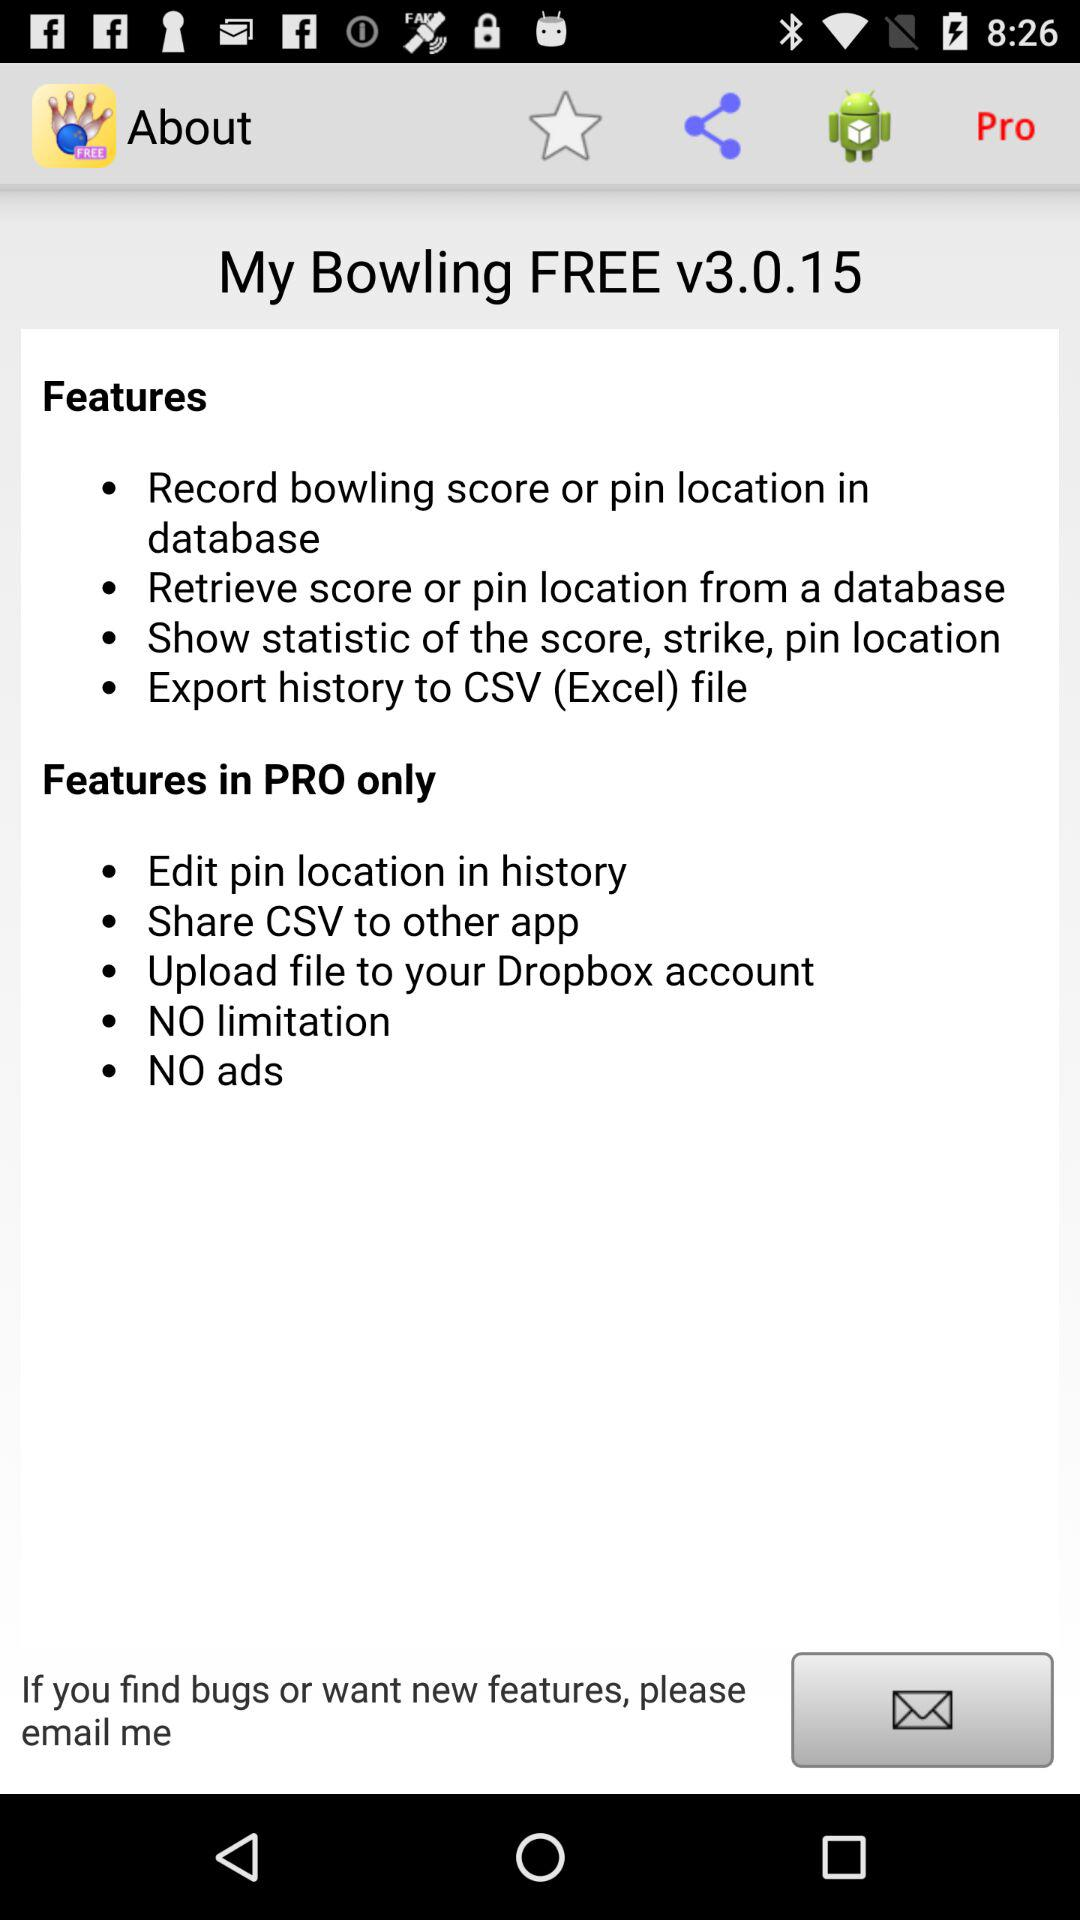What are the available features in the PRO version of the application? The available features are "Edit pin location in history", "Share CSV to other app", "Upload file to your Dropbox account", "NO limitation" and "NO ads". 